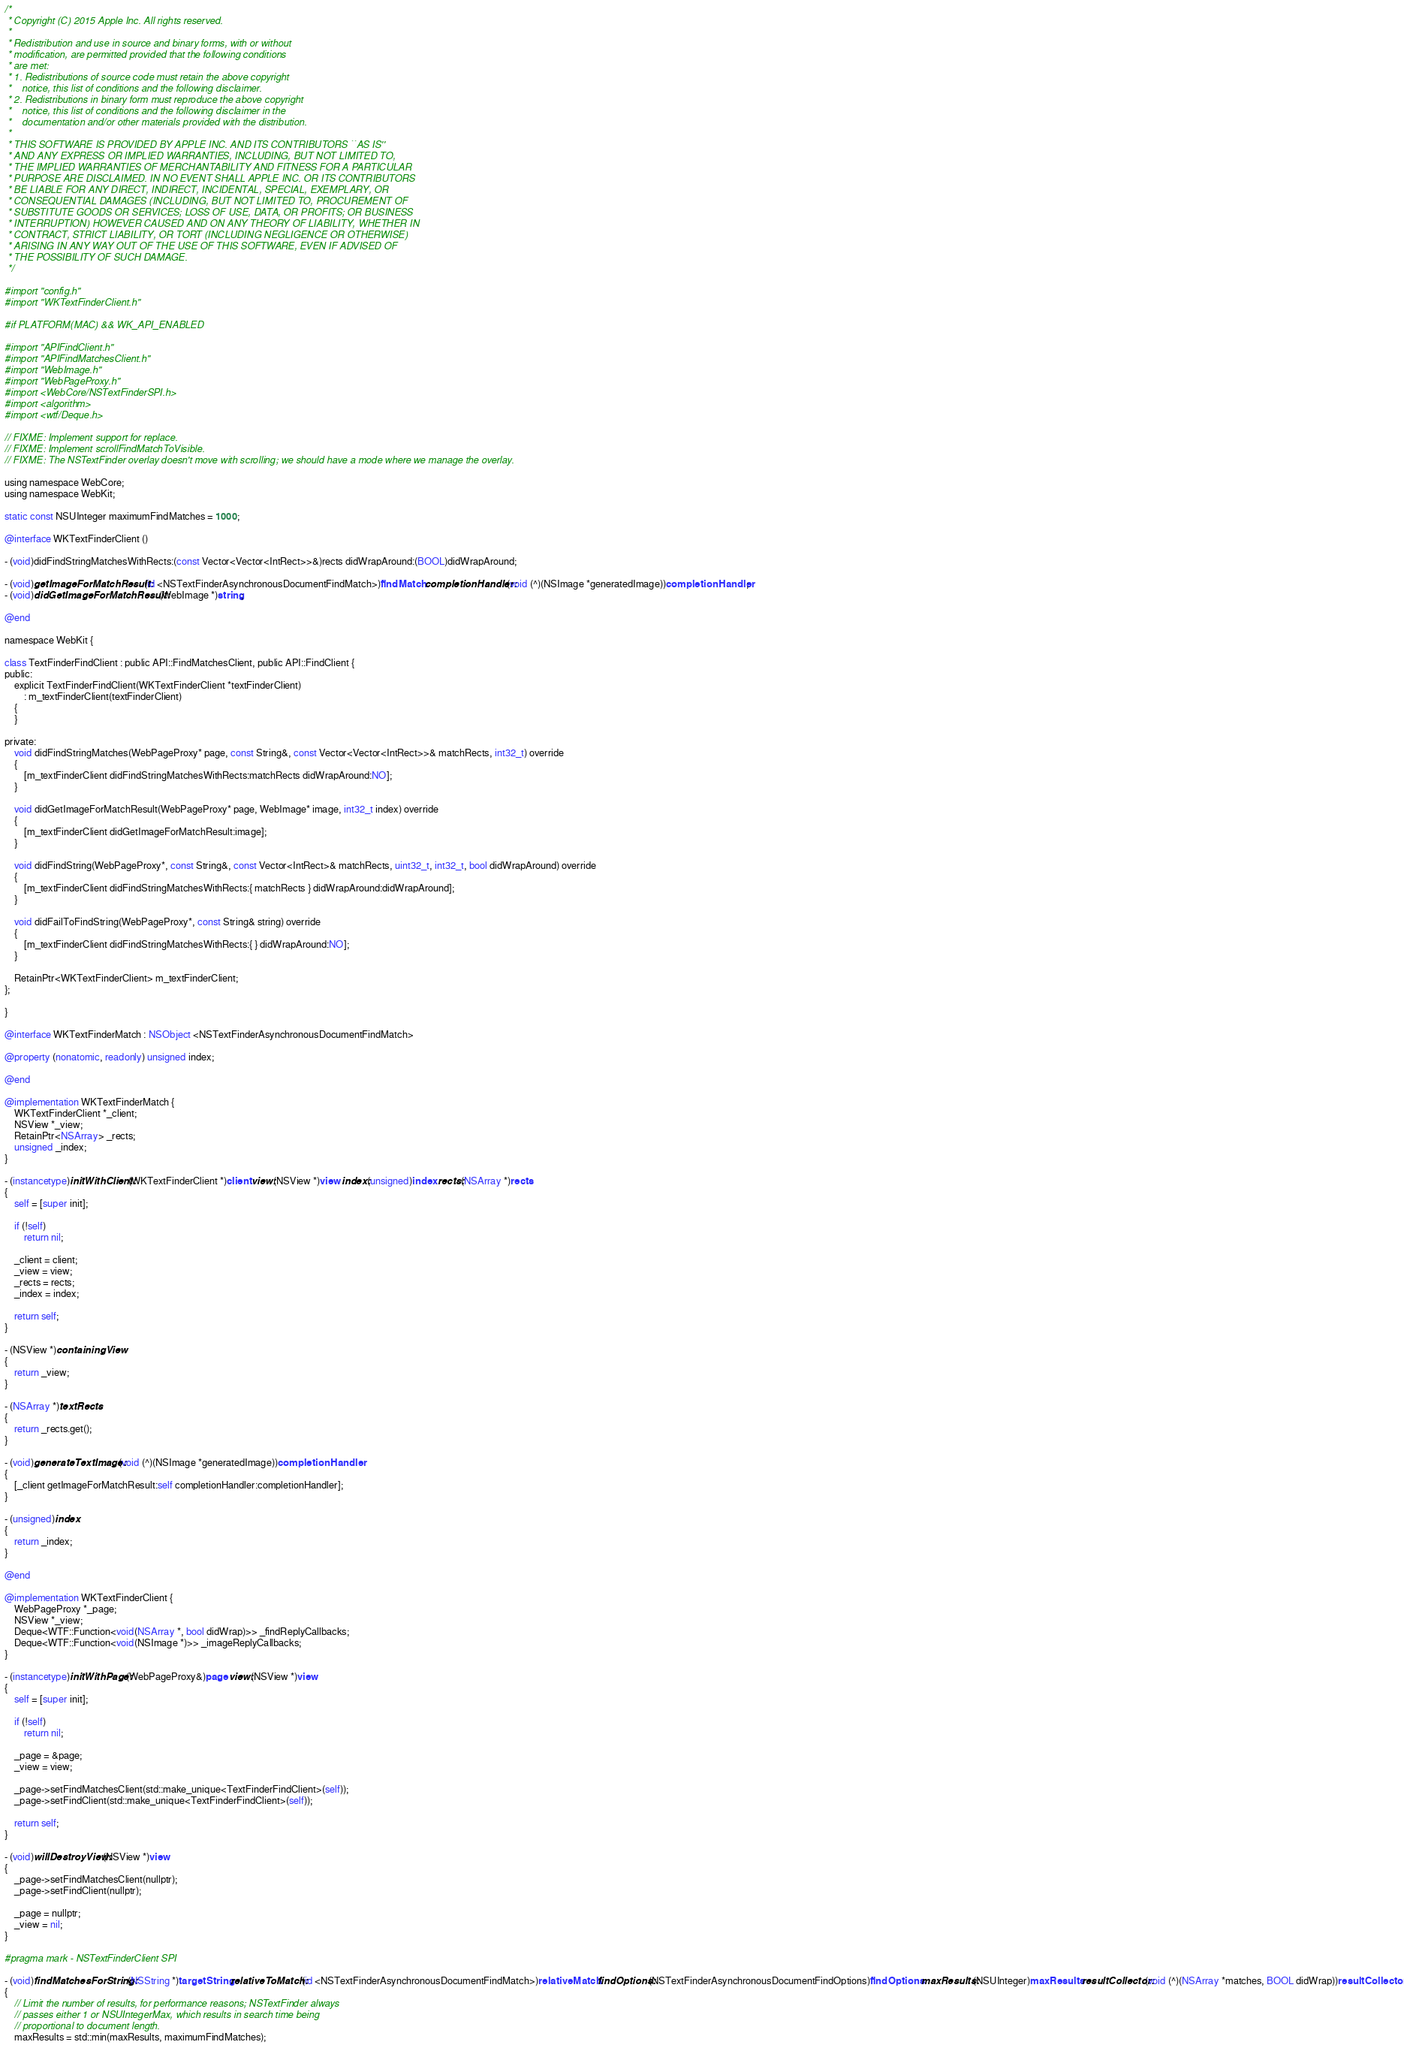Convert code to text. <code><loc_0><loc_0><loc_500><loc_500><_ObjectiveC_>/*
 * Copyright (C) 2015 Apple Inc. All rights reserved.
 *
 * Redistribution and use in source and binary forms, with or without
 * modification, are permitted provided that the following conditions
 * are met:
 * 1. Redistributions of source code must retain the above copyright
 *    notice, this list of conditions and the following disclaimer.
 * 2. Redistributions in binary form must reproduce the above copyright
 *    notice, this list of conditions and the following disclaimer in the
 *    documentation and/or other materials provided with the distribution.
 *
 * THIS SOFTWARE IS PROVIDED BY APPLE INC. AND ITS CONTRIBUTORS ``AS IS''
 * AND ANY EXPRESS OR IMPLIED WARRANTIES, INCLUDING, BUT NOT LIMITED TO,
 * THE IMPLIED WARRANTIES OF MERCHANTABILITY AND FITNESS FOR A PARTICULAR
 * PURPOSE ARE DISCLAIMED. IN NO EVENT SHALL APPLE INC. OR ITS CONTRIBUTORS
 * BE LIABLE FOR ANY DIRECT, INDIRECT, INCIDENTAL, SPECIAL, EXEMPLARY, OR
 * CONSEQUENTIAL DAMAGES (INCLUDING, BUT NOT LIMITED TO, PROCUREMENT OF
 * SUBSTITUTE GOODS OR SERVICES; LOSS OF USE, DATA, OR PROFITS; OR BUSINESS
 * INTERRUPTION) HOWEVER CAUSED AND ON ANY THEORY OF LIABILITY, WHETHER IN
 * CONTRACT, STRICT LIABILITY, OR TORT (INCLUDING NEGLIGENCE OR OTHERWISE)
 * ARISING IN ANY WAY OUT OF THE USE OF THIS SOFTWARE, EVEN IF ADVISED OF
 * THE POSSIBILITY OF SUCH DAMAGE.
 */

#import "config.h"
#import "WKTextFinderClient.h"

#if PLATFORM(MAC) && WK_API_ENABLED

#import "APIFindClient.h"
#import "APIFindMatchesClient.h"
#import "WebImage.h"
#import "WebPageProxy.h"
#import <WebCore/NSTextFinderSPI.h>
#import <algorithm>
#import <wtf/Deque.h>

// FIXME: Implement support for replace.
// FIXME: Implement scrollFindMatchToVisible.
// FIXME: The NSTextFinder overlay doesn't move with scrolling; we should have a mode where we manage the overlay.

using namespace WebCore;
using namespace WebKit;

static const NSUInteger maximumFindMatches = 1000;

@interface WKTextFinderClient ()

- (void)didFindStringMatchesWithRects:(const Vector<Vector<IntRect>>&)rects didWrapAround:(BOOL)didWrapAround;

- (void)getImageForMatchResult:(id <NSTextFinderAsynchronousDocumentFindMatch>)findMatch completionHandler:(void (^)(NSImage *generatedImage))completionHandler;
- (void)didGetImageForMatchResult:(WebImage *)string;

@end

namespace WebKit {

class TextFinderFindClient : public API::FindMatchesClient, public API::FindClient {
public:
    explicit TextFinderFindClient(WKTextFinderClient *textFinderClient)
        : m_textFinderClient(textFinderClient)
    {
    }

private:
    void didFindStringMatches(WebPageProxy* page, const String&, const Vector<Vector<IntRect>>& matchRects, int32_t) override
    {
        [m_textFinderClient didFindStringMatchesWithRects:matchRects didWrapAround:NO];
    }

    void didGetImageForMatchResult(WebPageProxy* page, WebImage* image, int32_t index) override
    {
        [m_textFinderClient didGetImageForMatchResult:image];
    }

    void didFindString(WebPageProxy*, const String&, const Vector<IntRect>& matchRects, uint32_t, int32_t, bool didWrapAround) override
    {
        [m_textFinderClient didFindStringMatchesWithRects:{ matchRects } didWrapAround:didWrapAround];
    }

    void didFailToFindString(WebPageProxy*, const String& string) override
    {
        [m_textFinderClient didFindStringMatchesWithRects:{ } didWrapAround:NO];
    }

    RetainPtr<WKTextFinderClient> m_textFinderClient;
};
    
}

@interface WKTextFinderMatch : NSObject <NSTextFinderAsynchronousDocumentFindMatch>

@property (nonatomic, readonly) unsigned index;

@end

@implementation WKTextFinderMatch {
    WKTextFinderClient *_client;
    NSView *_view;
    RetainPtr<NSArray> _rects;
    unsigned _index;
}

- (instancetype)initWithClient:(WKTextFinderClient *)client view:(NSView *)view index:(unsigned)index rects:(NSArray *)rects
{
    self = [super init];

    if (!self)
        return nil;

    _client = client;
    _view = view;
    _rects = rects;
    _index = index;

    return self;
}

- (NSView *)containingView
{
    return _view;
}

- (NSArray *)textRects
{
    return _rects.get();
}

- (void)generateTextImage:(void (^)(NSImage *generatedImage))completionHandler
{
    [_client getImageForMatchResult:self completionHandler:completionHandler];
}

- (unsigned)index
{
    return _index;
}

@end

@implementation WKTextFinderClient {
    WebPageProxy *_page;
    NSView *_view;
    Deque<WTF::Function<void(NSArray *, bool didWrap)>> _findReplyCallbacks;
    Deque<WTF::Function<void(NSImage *)>> _imageReplyCallbacks;
}

- (instancetype)initWithPage:(WebPageProxy&)page view:(NSView *)view
{
    self = [super init];

    if (!self)
        return nil;

    _page = &page;
    _view = view;
    
    _page->setFindMatchesClient(std::make_unique<TextFinderFindClient>(self));
    _page->setFindClient(std::make_unique<TextFinderFindClient>(self));

    return self;
}

- (void)willDestroyView:(NSView *)view
{
    _page->setFindMatchesClient(nullptr);
    _page->setFindClient(nullptr);

    _page = nullptr;
    _view = nil;
}

#pragma mark - NSTextFinderClient SPI

- (void)findMatchesForString:(NSString *)targetString relativeToMatch:(id <NSTextFinderAsynchronousDocumentFindMatch>)relativeMatch findOptions:(NSTextFinderAsynchronousDocumentFindOptions)findOptions maxResults:(NSUInteger)maxResults resultCollector:(void (^)(NSArray *matches, BOOL didWrap))resultCollector
{
    // Limit the number of results, for performance reasons; NSTextFinder always
    // passes either 1 or NSUIntegerMax, which results in search time being
    // proportional to document length.
    maxResults = std::min(maxResults, maximumFindMatches);
</code> 